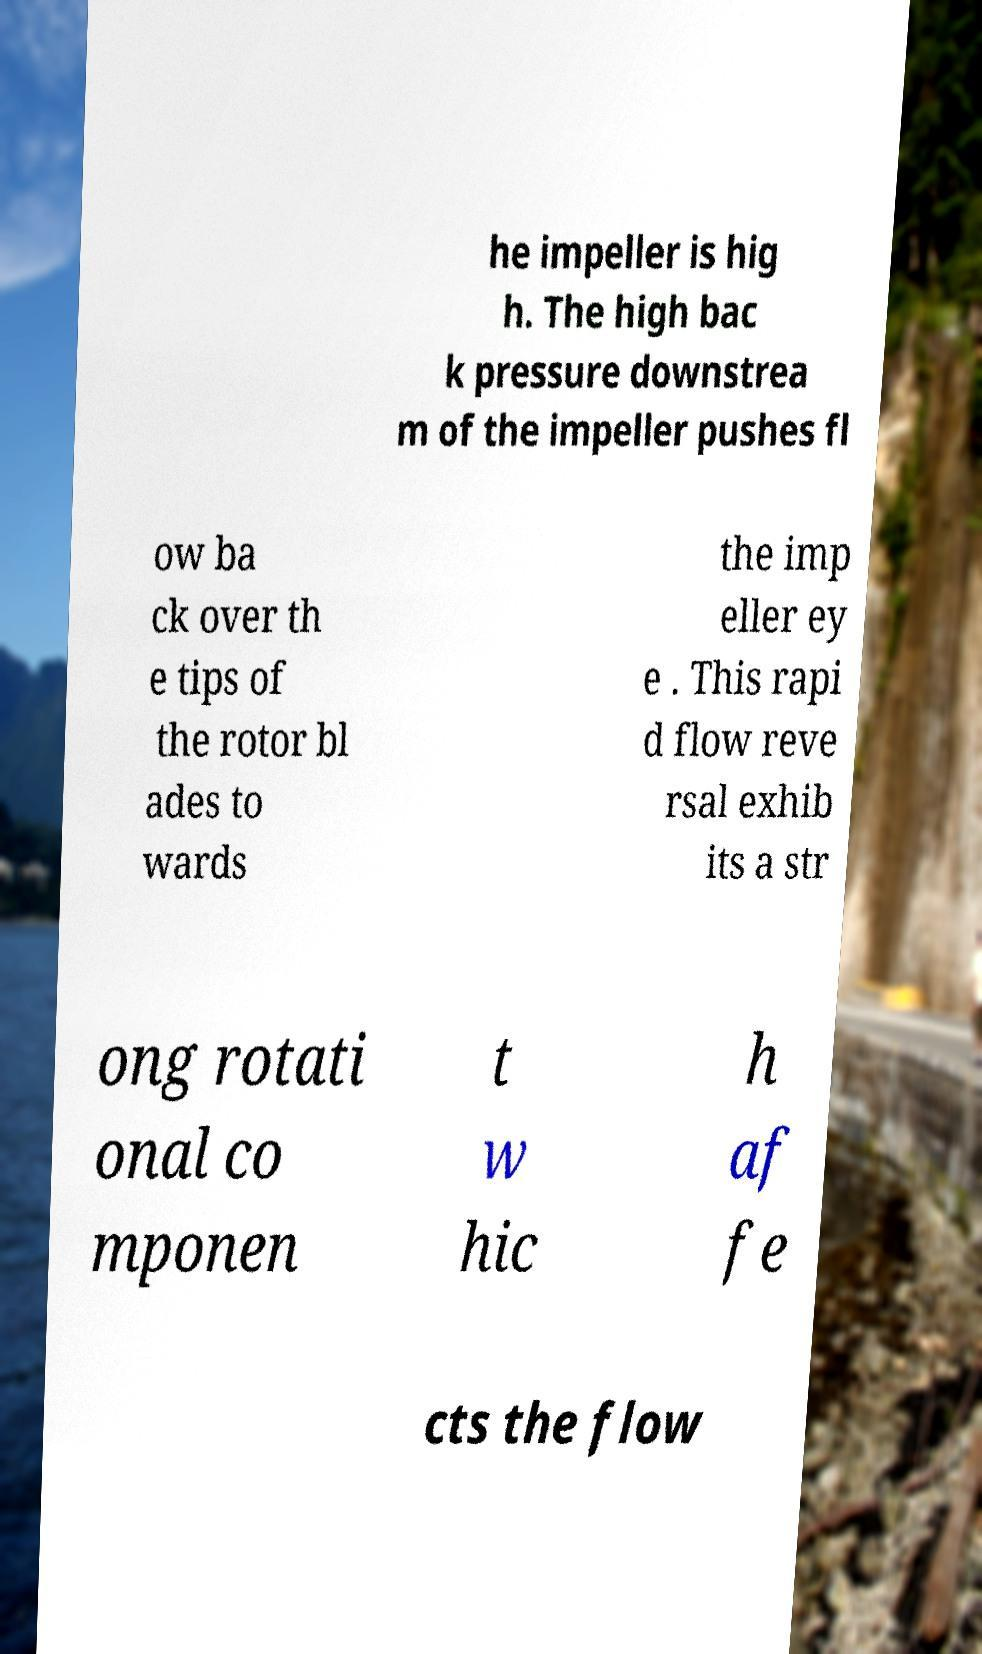Could you extract and type out the text from this image? he impeller is hig h. The high bac k pressure downstrea m of the impeller pushes fl ow ba ck over th e tips of the rotor bl ades to wards the imp eller ey e . This rapi d flow reve rsal exhib its a str ong rotati onal co mponen t w hic h af fe cts the flow 